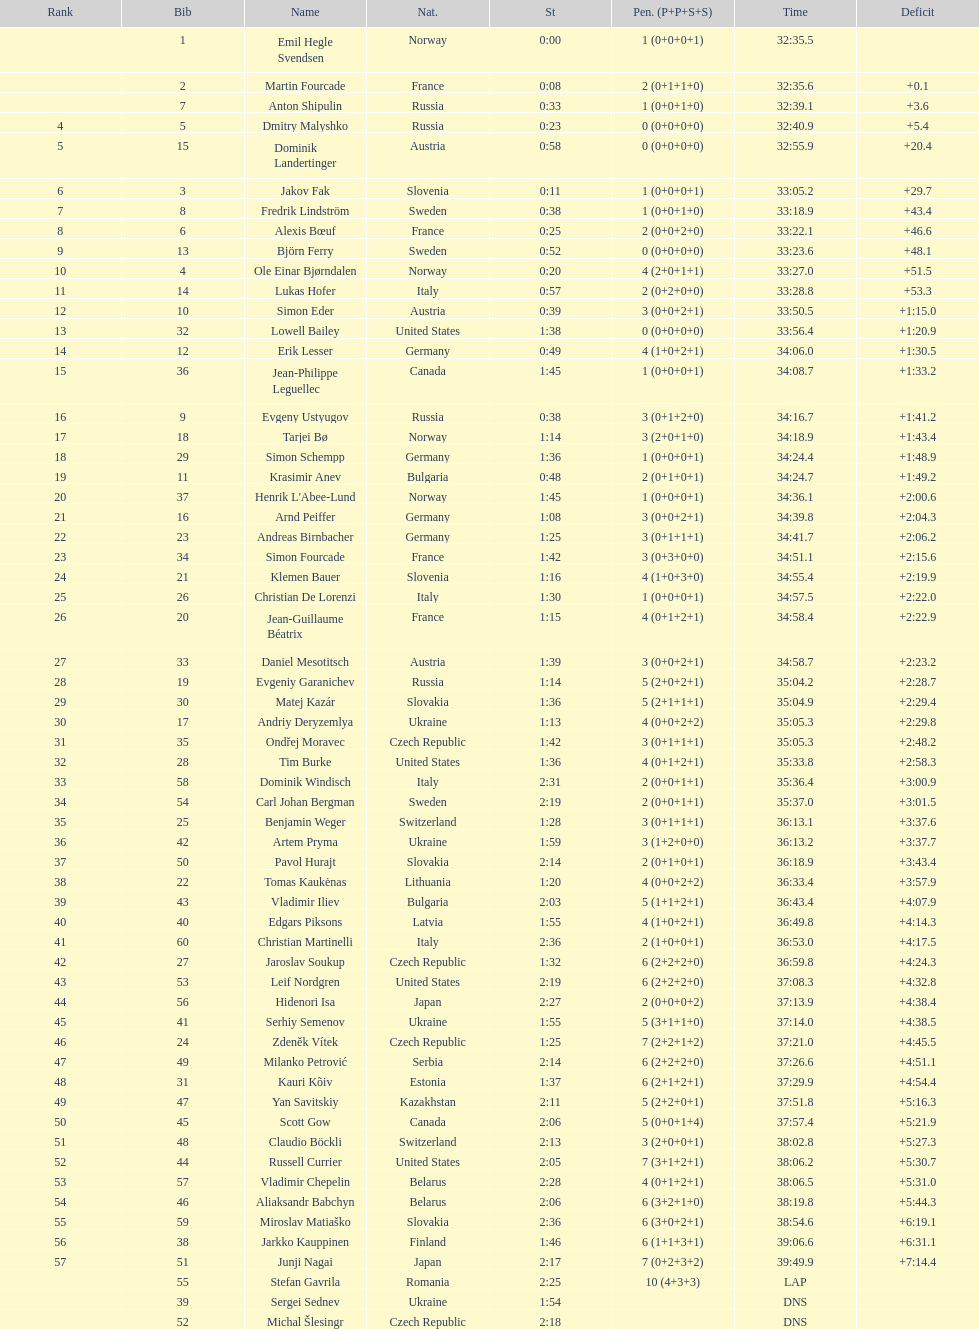How many penalties did germany get all together? 11. 